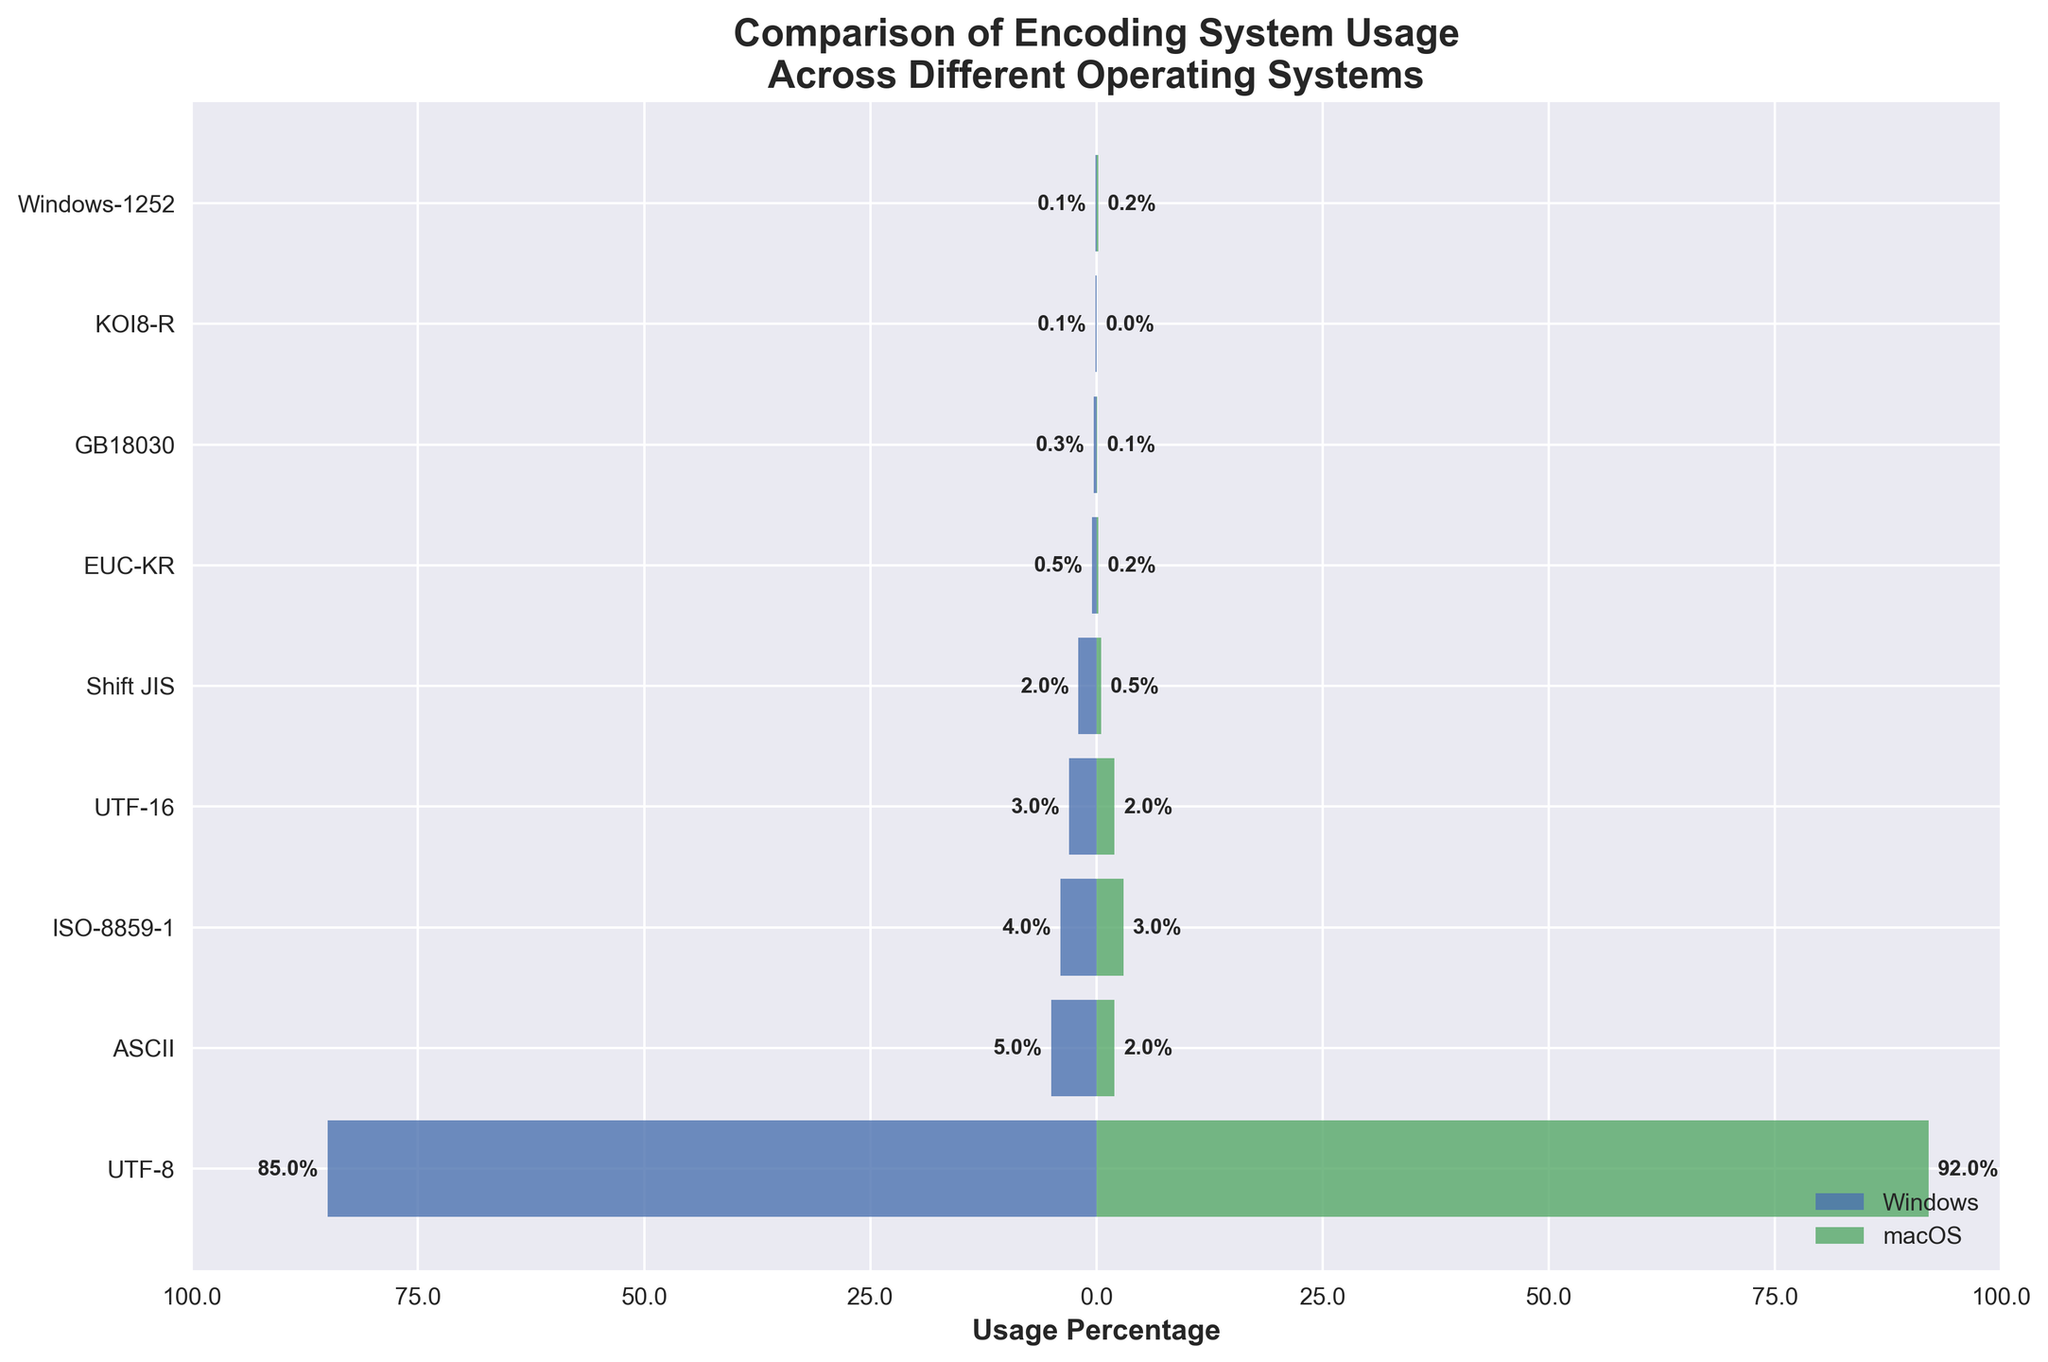How many different encoding systems are shown in the plot? To determine the number of different encoding systems shown, we count the unique encodings listed on the vertical axis of the figure.
Answer: 9 Which encoding system has the highest usage percentage on Windows? By looking at the lengths of the horizontal bars on the Windows (left) side, we identify the encoding system with the longest bar.
Answer: UTF-8 Which encoding system has the smallest usage percentage on macOS? By looking at the macOS (right) side and identifying the bar with the smallest length, we find the encoding system with the smallest usage percentage.
Answer: KOI8-R What is the usage difference of UTF-8 between Windows and macOS? To find the difference, subtract the windows value from the macOS value for UTF-8. The values are 85 for Windows and 92 for macOS. 92 - 85 = 7
Answer: 7 What is the combined usage percentage for ISO-8859-1 on both Windows and macOS? To calculate this, add the percentage for Windows and macOS versions of ISO-8859-1. The values are 4 for Windows and 3 for macOS. 4 + 3 = 7
Answer: 7 Which encoding system has a higher percentage of usage on macOS compared to Windows? We check the horizontal bars and find the encoding system where the macOS bar extends further than the Windows bar.
Answer: UTF-8 What is the percentage difference between the usage of ASCII on Windows and macOS? Subtract the smaller value (macOS) from the larger value (Windows). ASCII has 5% on Windows and 2% on macOS. 5 - 2 = 3
Answer: 3 List the encoding systems where usage on Windows is less than 1%. We look at the Windows side and identify the encoding systems where the bars are very short.
Answer: EUC-KR, GB18030, KOI8-R, Windows-1252 By how much does the usage of UTF-16 differ between Windows and macOS? Subtract the usage percentage of macOS from that of Windows for UTF-16. The values are 3 for Windows and 2 for macOS. 3 - 2 = 1
Answer: 1 If we combine the Windows usage percentages for UTF-8, ASCII, and ISO-8859-1, what would be the total percentage? Add the usages together: UTF-8 (85) + ASCII (5) + ISO-8859-1 (4). 85 + 5 + 4 = 94
Answer: 94 